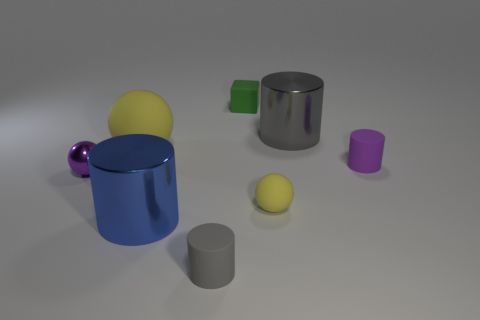The gray object that is the same material as the tiny block is what size?
Your answer should be very brief. Small. What number of cylinders are either big yellow matte objects or blue shiny things?
Ensure brevity in your answer.  1. Is the number of tiny gray shiny cubes greater than the number of small gray cylinders?
Your answer should be compact. No. What number of purple cylinders have the same size as the gray metal object?
Ensure brevity in your answer.  0. There is a tiny rubber thing that is the same color as the small shiny sphere; what shape is it?
Keep it short and to the point. Cylinder. What number of objects are objects that are on the right side of the big gray shiny cylinder or big red spheres?
Offer a terse response. 1. Is the number of gray metallic cylinders less than the number of small yellow metal cylinders?
Offer a terse response. No. The big gray object that is the same material as the purple sphere is what shape?
Offer a terse response. Cylinder. There is a tiny yellow matte thing; are there any big blue objects behind it?
Keep it short and to the point. No. Are there fewer large blue metallic things on the right side of the purple sphere than rubber cylinders?
Ensure brevity in your answer.  Yes. 